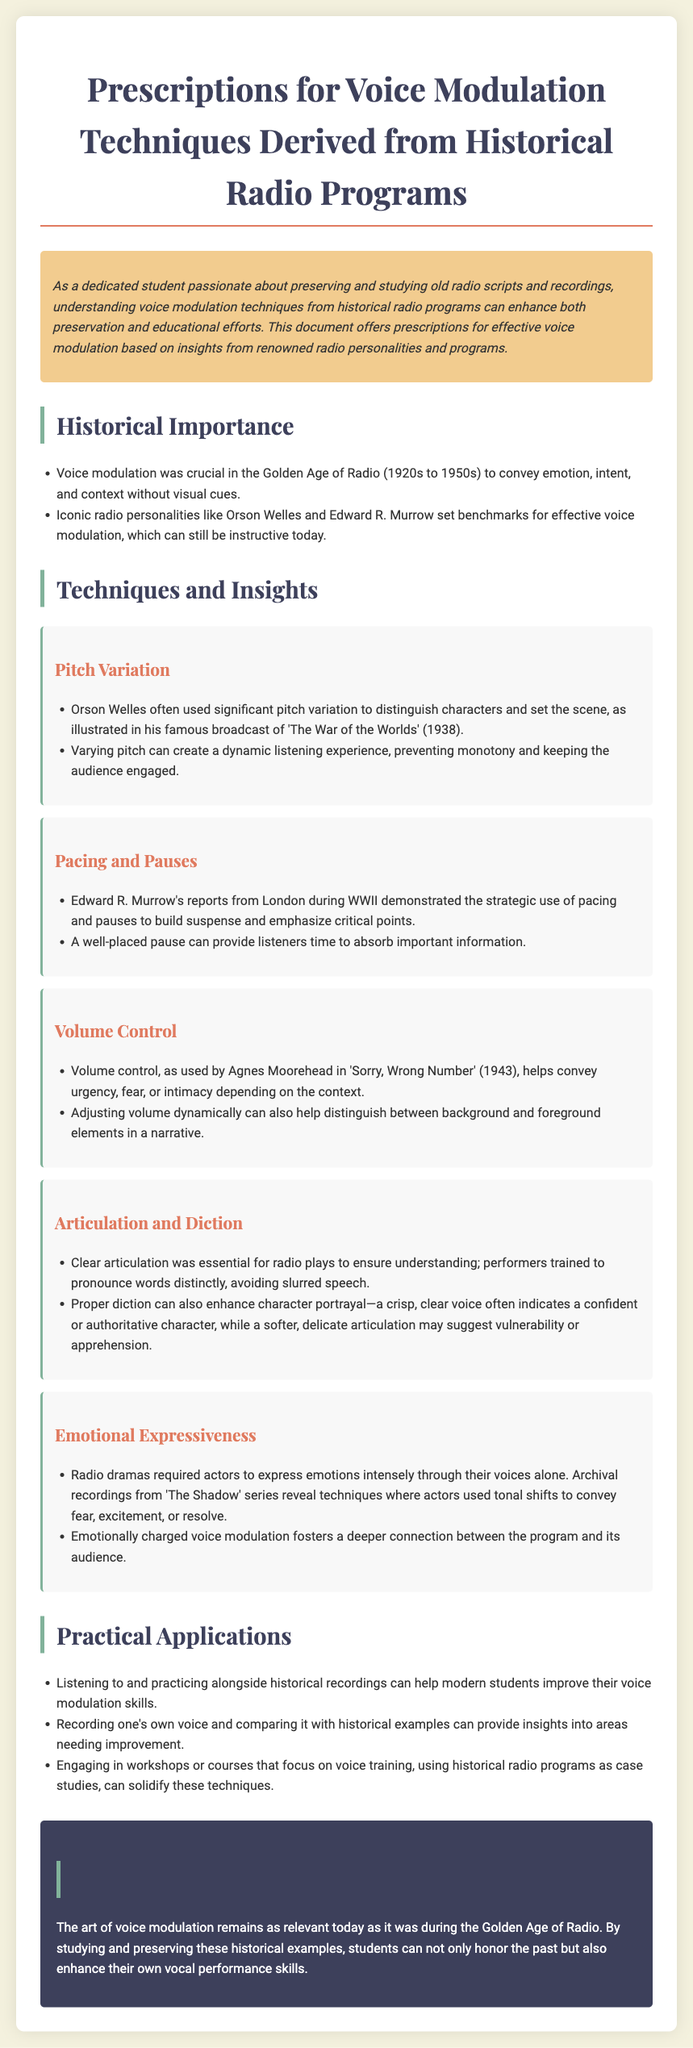What is the title of the document? The title can be found at the top of the document, which summarizes its main focus.
Answer: Prescriptions for Voice Modulation Techniques Derived from Historical Radio Programs Who is mentioned as a key figure for pitch variation? The document discusses Orson Welles in relation to pitch variation in voice modulation techniques.
Answer: Orson Welles What year was 'The War of the Worlds' broadcast? The document states the year of the broadcast that is relevant to the discussion on pitch variation.
Answer: 1938 Which radio personality demonstrated pacing and pauses? Edward R. Murrow is referenced as the radio personality known for strategic pacing and pauses.
Answer: Edward R. Murrow Name one technique for improving voice modulation. The Practical Applications section outlines specific techniques for enhancing voice modulation skills, one of which is listening to historical recordings.
Answer: Listening to and practicing alongside historical recordings What does clear articulation ensure according to the document? Clear articulation is emphasized in the document for a specific purpose related to understanding in radio plays.
Answer: Understanding What emotional aspect is crucial for voice modulation? The document discusses the importance of expressing emotions to establish a connection with the audience.
Answer: Emotional Expressiveness What type of document is this? The structural elements and content indicate that this document serves a specific purpose related to recommendations.
Answer: Prescription 